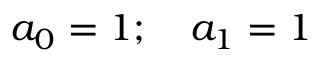Convert formula to latex. <formula><loc_0><loc_0><loc_500><loc_500>a _ { 0 } = 1 ; \quad a _ { 1 } = 1</formula> 